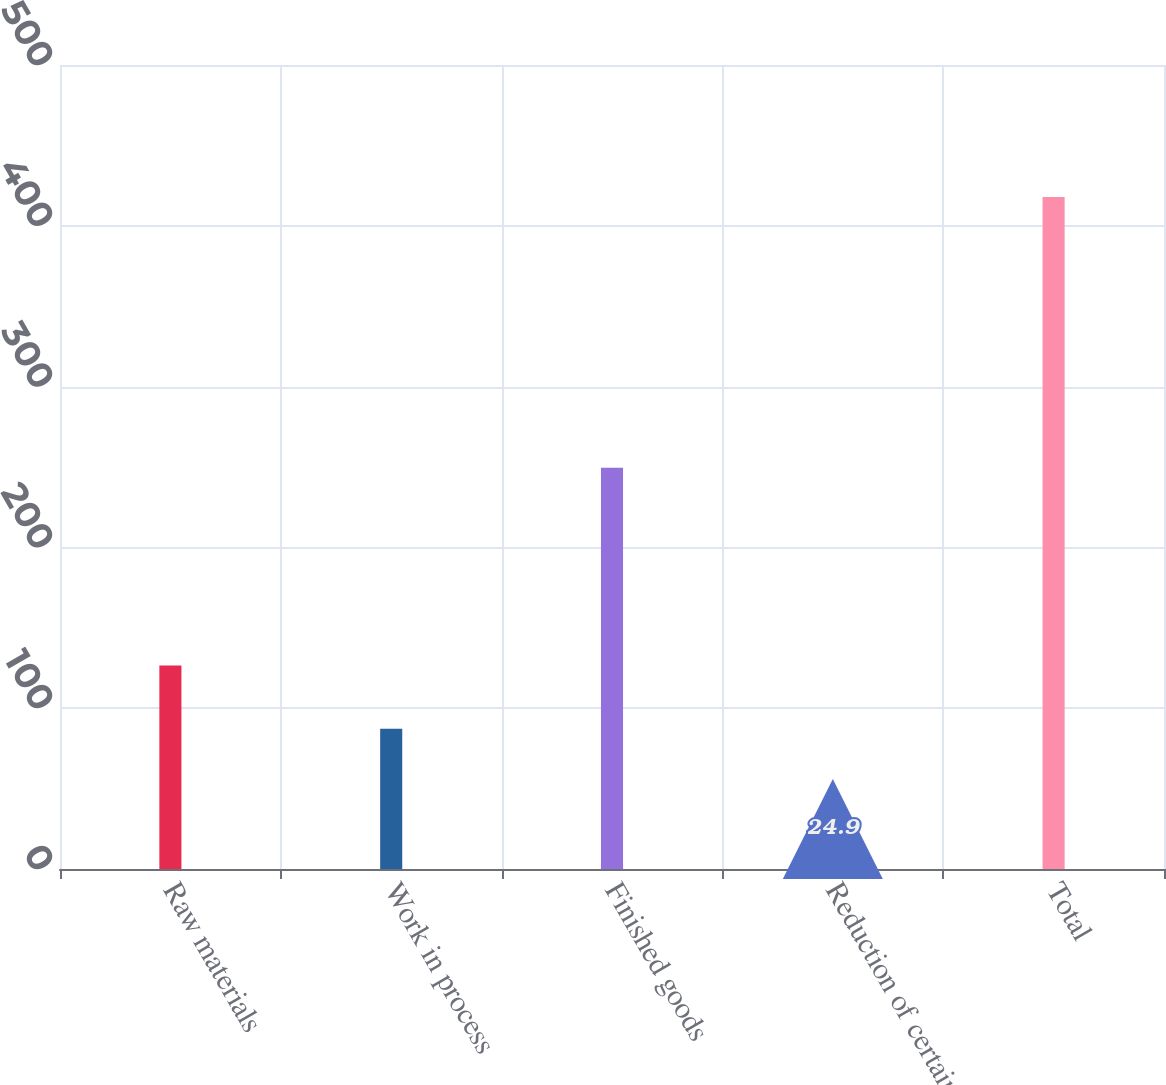<chart> <loc_0><loc_0><loc_500><loc_500><bar_chart><fcel>Raw materials<fcel>Work in process<fcel>Finished goods<fcel>Reduction of certain<fcel>Total<nl><fcel>126.5<fcel>87.2<fcel>249.5<fcel>24.9<fcel>417.9<nl></chart> 